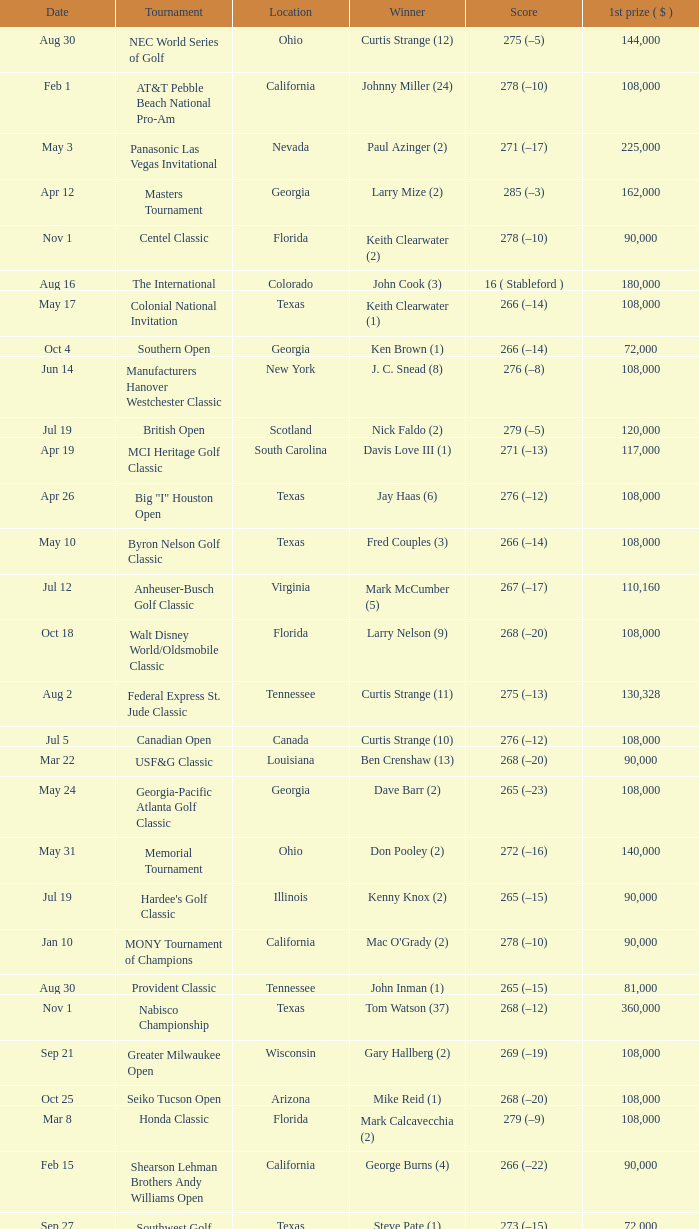What is the score from the winner Keith Clearwater (1)? 266 (–14). 